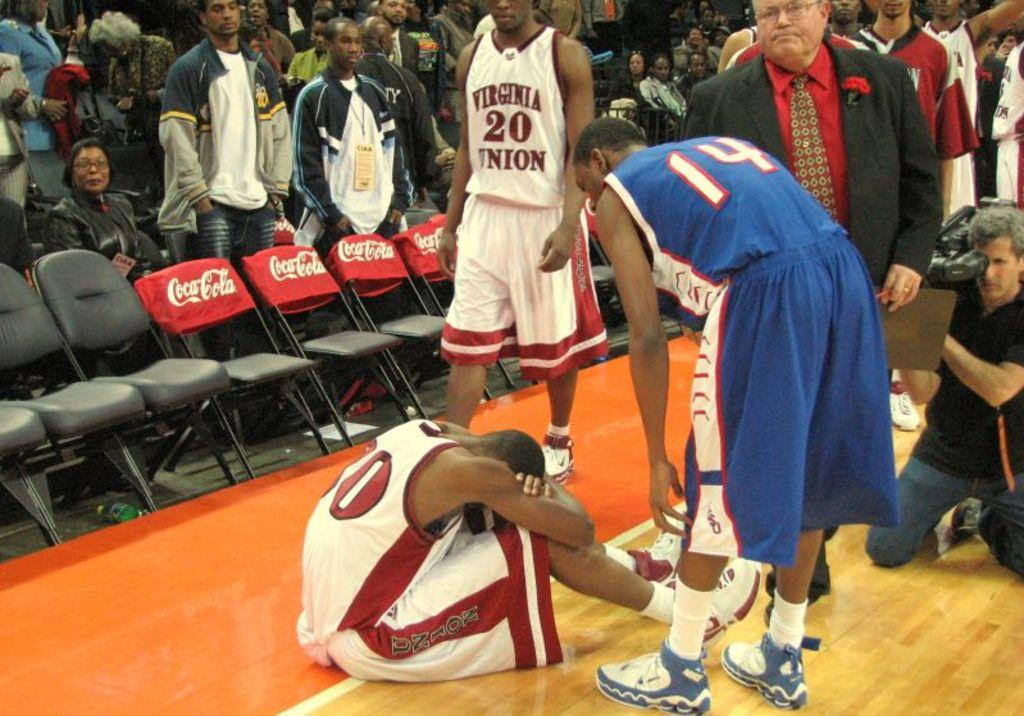<image>
Write a terse but informative summary of the picture. Player number 14 in blue consoles his opponent from Virginia Union 